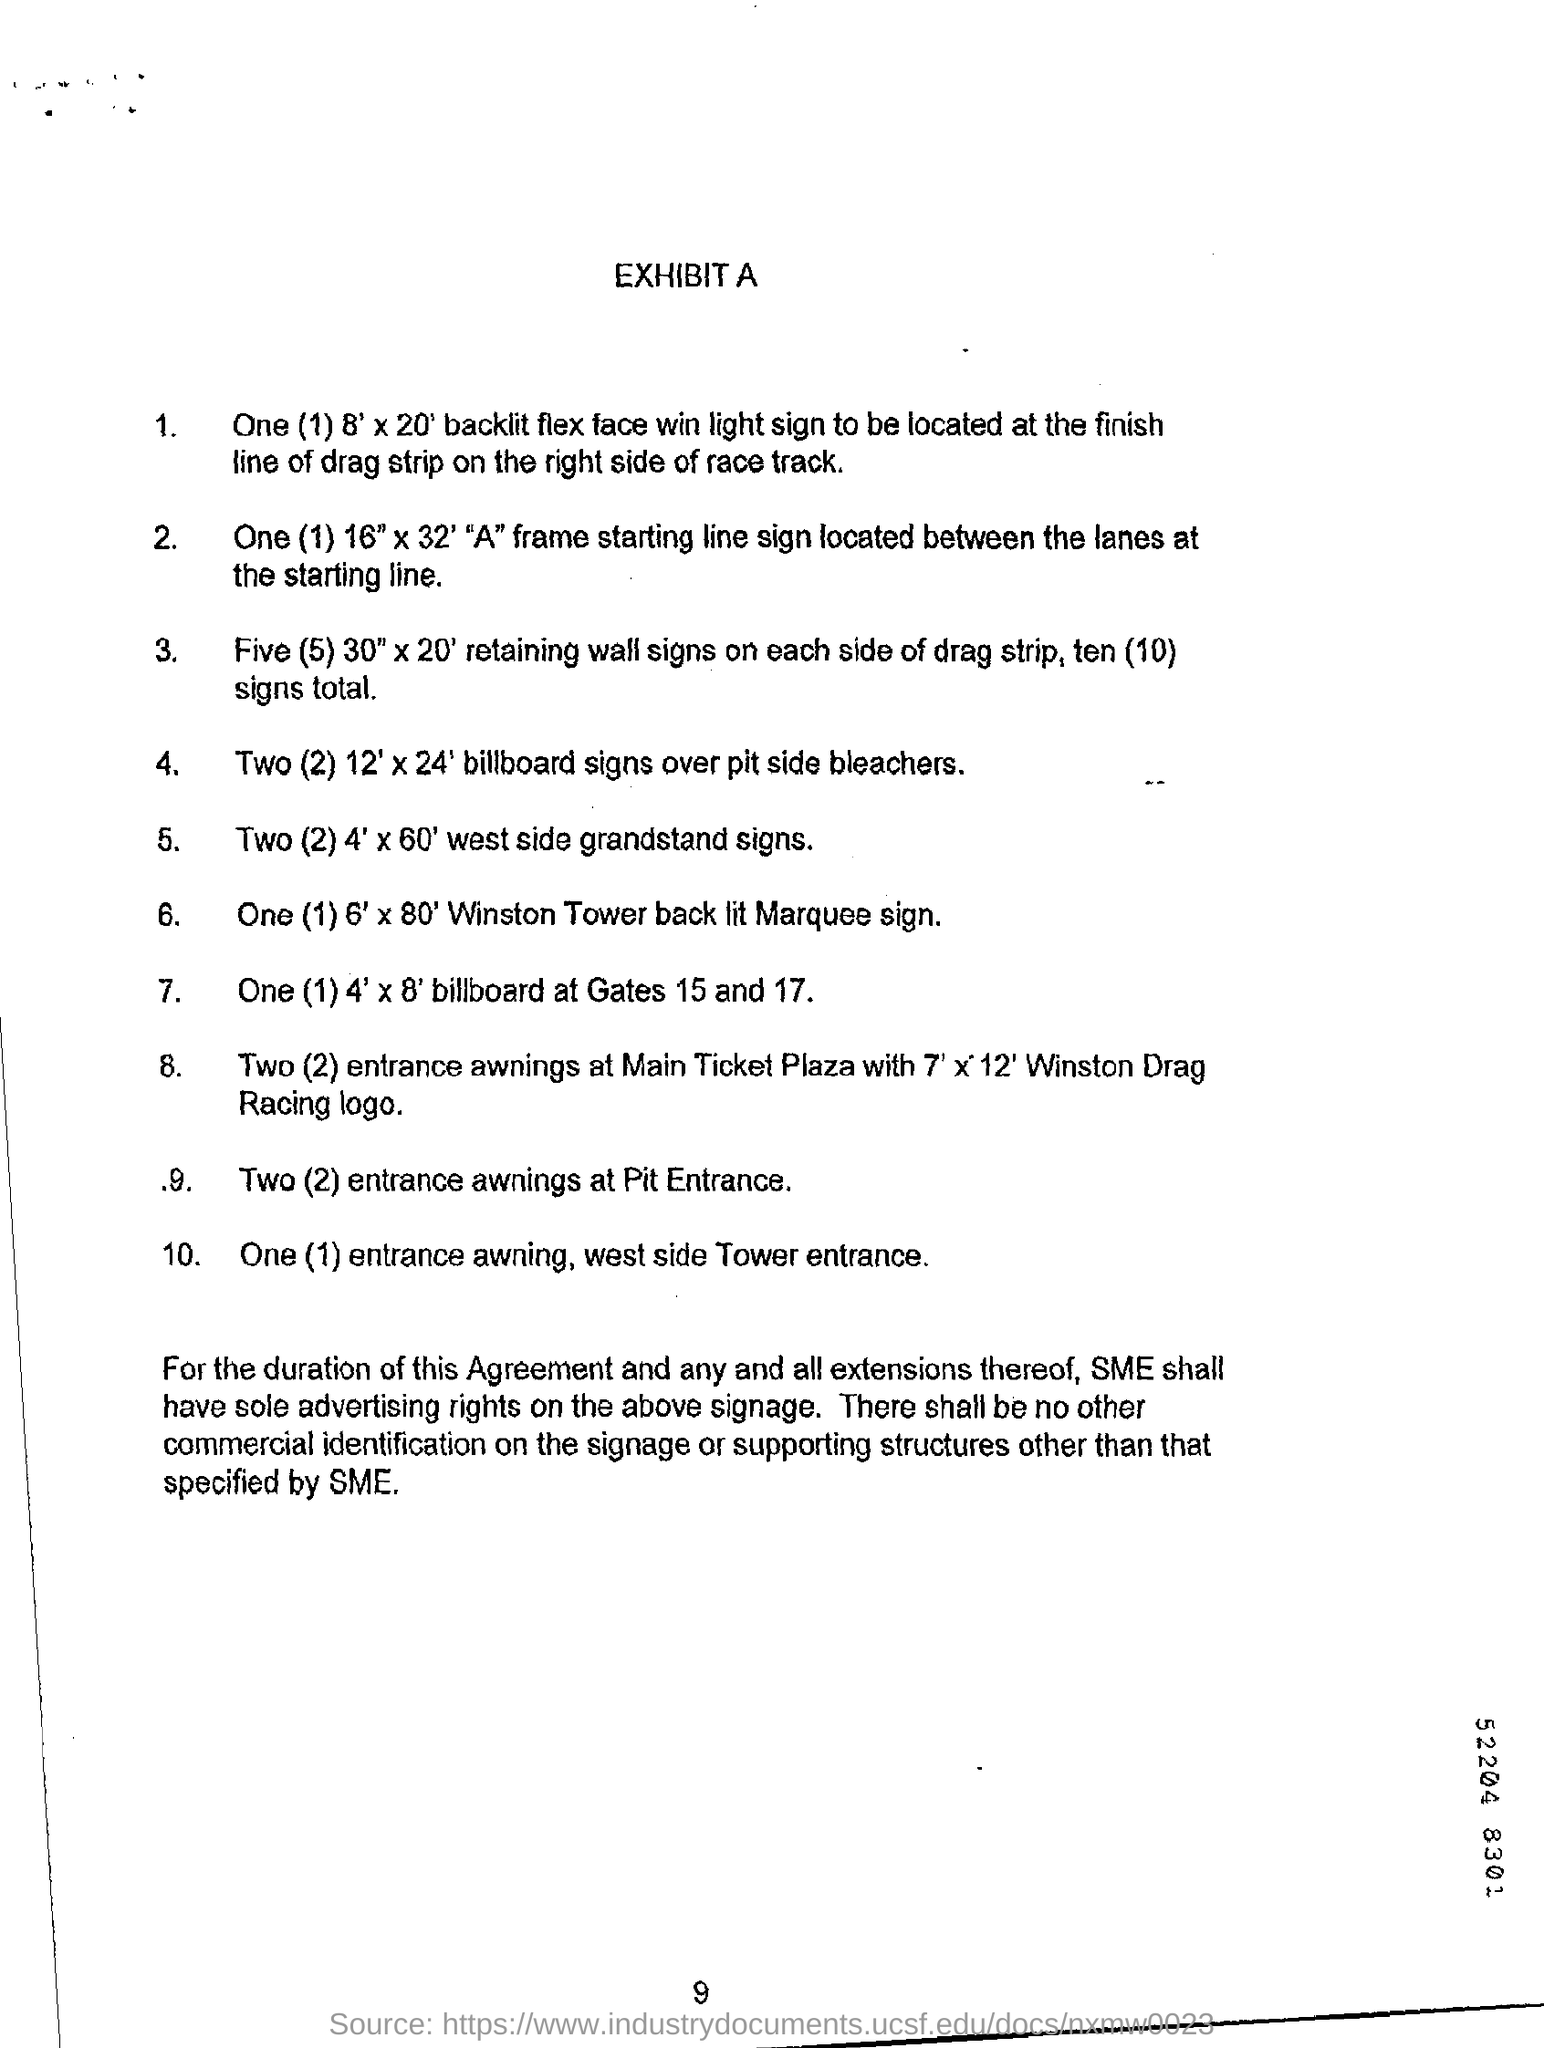What is the number at bottom of the page ?
Offer a terse response. 9. What is the heading at top of the page ?
Give a very brief answer. Exhibit A. 